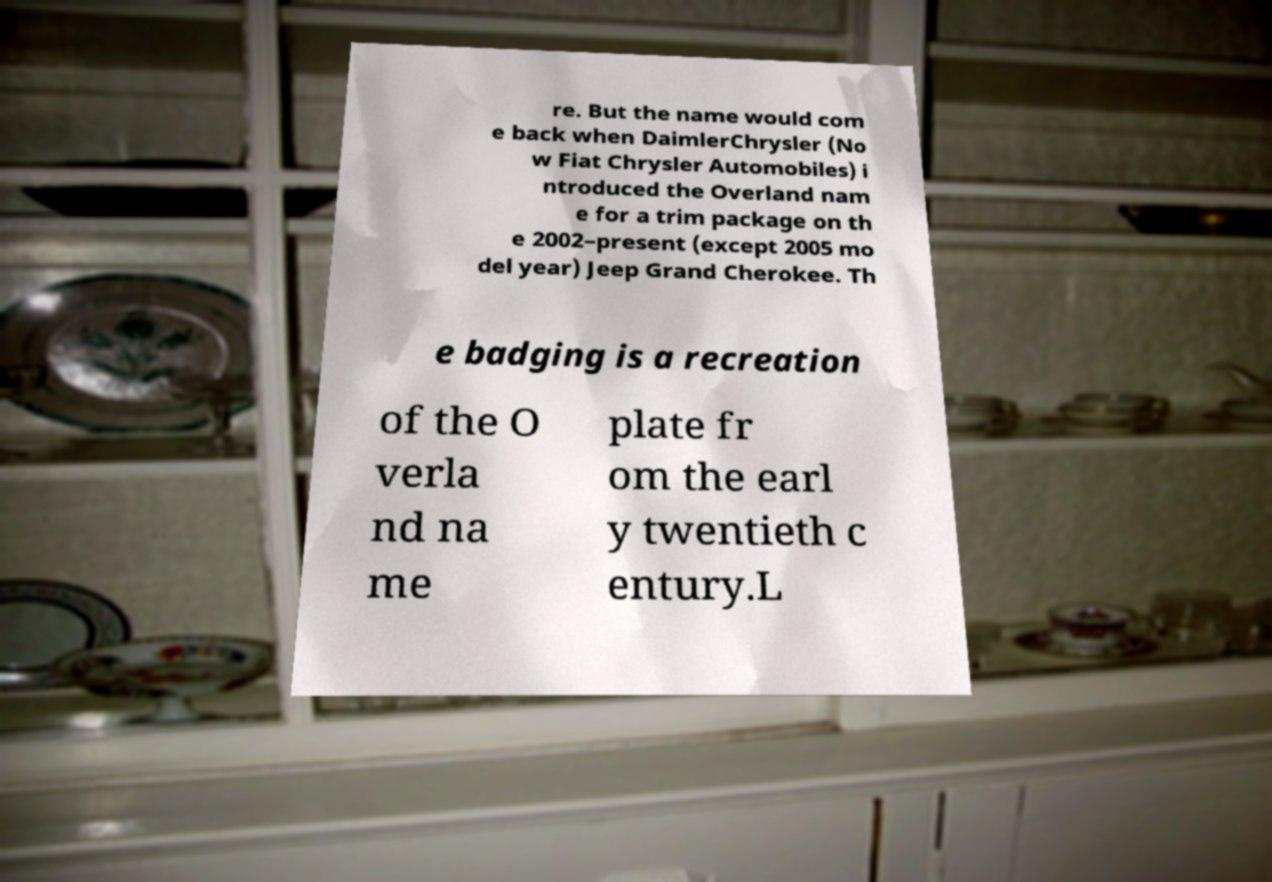I need the written content from this picture converted into text. Can you do that? re. But the name would com e back when DaimlerChrysler (No w Fiat Chrysler Automobiles) i ntroduced the Overland nam e for a trim package on th e 2002–present (except 2005 mo del year) Jeep Grand Cherokee. Th e badging is a recreation of the O verla nd na me plate fr om the earl y twentieth c entury.L 